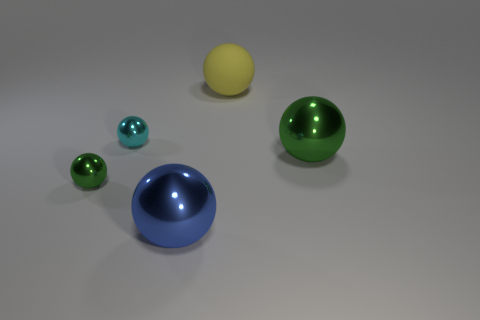Can you tell me the colors of the spheres and their relative size order? Certainly! Starting with the largest, there's a green sphere, followed by a blue hemisphere, then a yellow sphere, and finally, the two smaller spheres are cyan. So, from largest to smallest, the order is green, blue, yellow, cyan. 